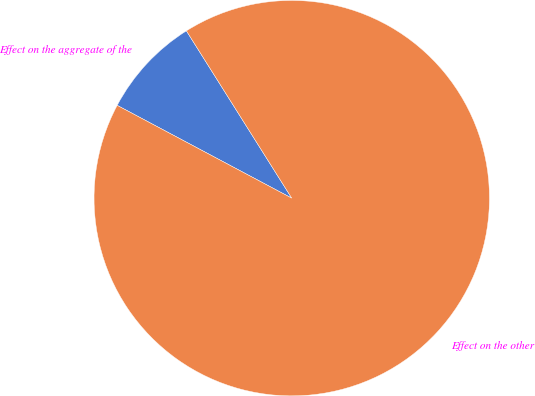Convert chart to OTSL. <chart><loc_0><loc_0><loc_500><loc_500><pie_chart><fcel>Effect on the aggregate of the<fcel>Effect on the other<nl><fcel>8.28%<fcel>91.72%<nl></chart> 